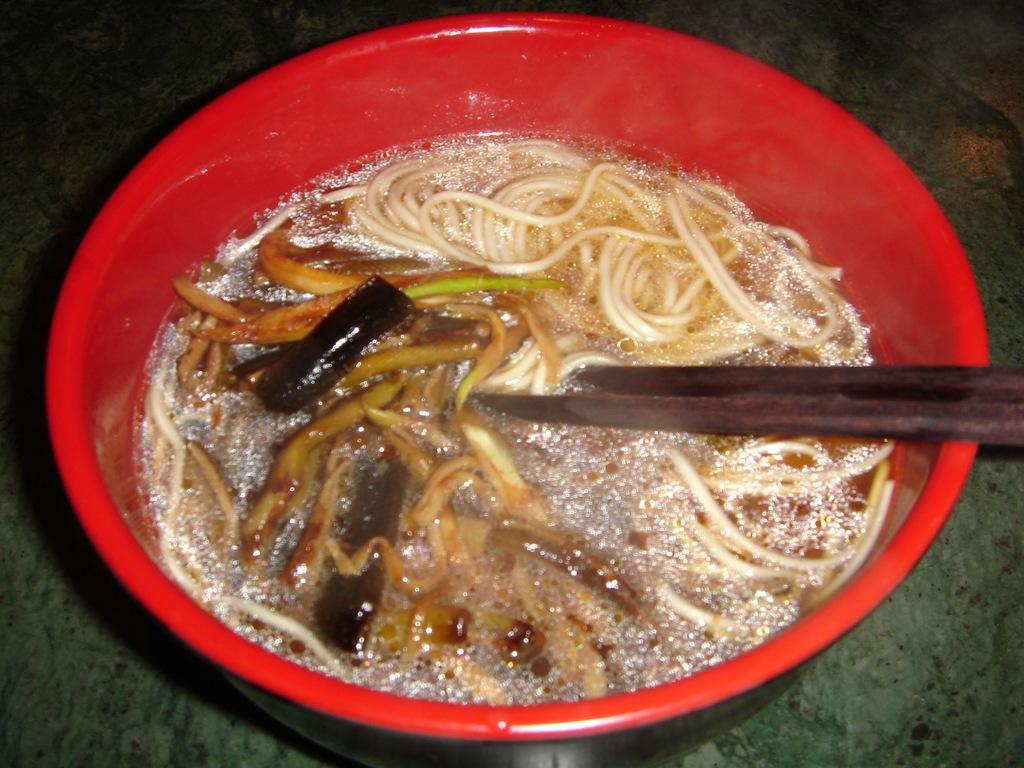What is in the bowl that is visible in the image? There is a bowl in the image, and it contains soup and spaghetti. What utensil is present in the bowl? There is a spoon in the bowl. What type of branch can be seen growing from the soup in the image? There is no branch growing from the soup in the image; it is a bowl of soup and spaghetti with a spoon. 